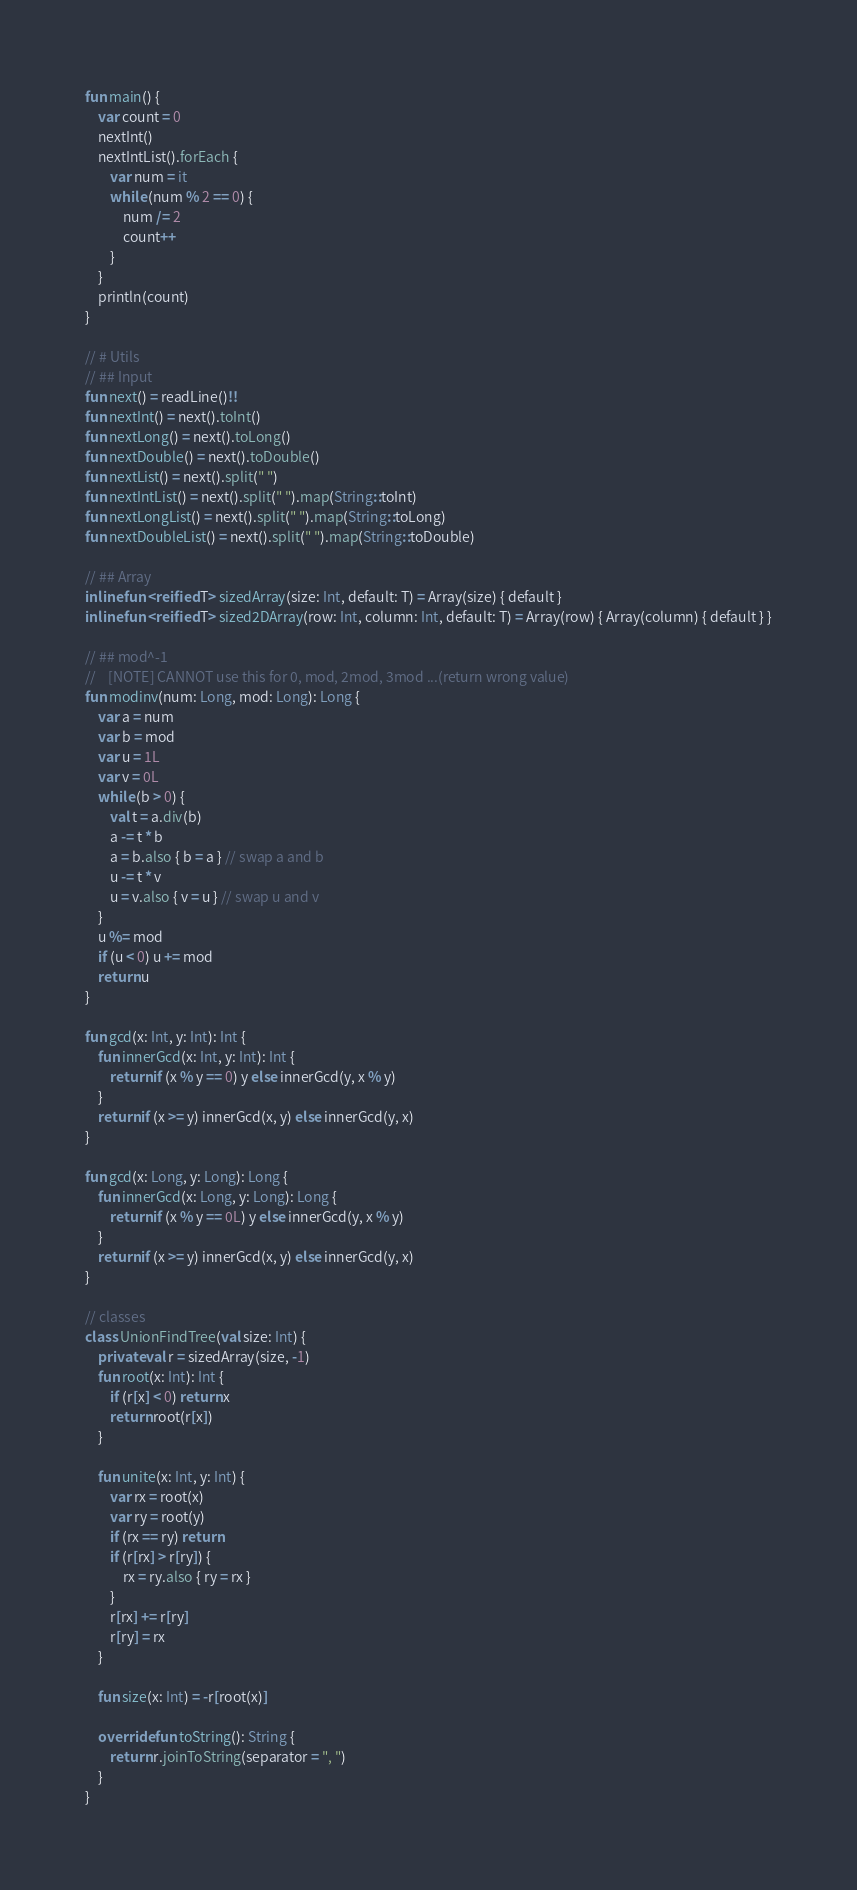Convert code to text. <code><loc_0><loc_0><loc_500><loc_500><_Kotlin_>fun main() {
    var count = 0
    nextInt()
    nextIntList().forEach {
        var num = it
        while (num % 2 == 0) {
            num /= 2
            count++
        }
    }
    println(count)
}

// # Utils
// ## Input
fun next() = readLine()!!
fun nextInt() = next().toInt()
fun nextLong() = next().toLong()
fun nextDouble() = next().toDouble()
fun nextList() = next().split(" ")
fun nextIntList() = next().split(" ").map(String::toInt)
fun nextLongList() = next().split(" ").map(String::toLong)
fun nextDoubleList() = next().split(" ").map(String::toDouble)

// ## Array
inline fun <reified T> sizedArray(size: Int, default: T) = Array(size) { default }
inline fun <reified T> sized2DArray(row: Int, column: Int, default: T) = Array(row) { Array(column) { default } }

// ## mod^-1
//    [NOTE] CANNOT use this for 0, mod, 2mod, 3mod ...(return wrong value)
fun modinv(num: Long, mod: Long): Long {
    var a = num
    var b = mod
    var u = 1L
    var v = 0L
    while (b > 0) {
        val t = a.div(b)
        a -= t * b
        a = b.also { b = a } // swap a and b
        u -= t * v
        u = v.also { v = u } // swap u and v
    }
    u %= mod
    if (u < 0) u += mod
    return u
}

fun gcd(x: Int, y: Int): Int {
    fun innerGcd(x: Int, y: Int): Int {
        return if (x % y == 0) y else innerGcd(y, x % y)
    }
    return if (x >= y) innerGcd(x, y) else innerGcd(y, x)
}

fun gcd(x: Long, y: Long): Long {
    fun innerGcd(x: Long, y: Long): Long {
        return if (x % y == 0L) y else innerGcd(y, x % y)
    }
    return if (x >= y) innerGcd(x, y) else innerGcd(y, x)
}

// classes
class UnionFindTree(val size: Int) {
    private val r = sizedArray(size, -1)
    fun root(x: Int): Int {
        if (r[x] < 0) return x
        return root(r[x])
    }

    fun unite(x: Int, y: Int) {
        var rx = root(x)
        var ry = root(y)
        if (rx == ry) return
        if (r[rx] > r[ry]) {
            rx = ry.also { ry = rx }
        }
        r[rx] += r[ry]
        r[ry] = rx
    }

    fun size(x: Int) = -r[root(x)]

    override fun toString(): String {
        return r.joinToString(separator = ", ")
    }
}</code> 